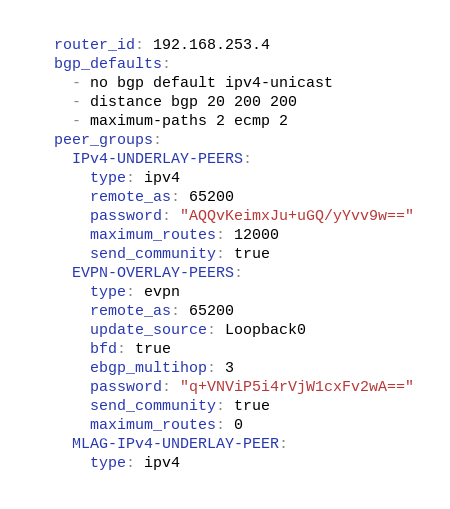<code> <loc_0><loc_0><loc_500><loc_500><_YAML_>  router_id: 192.168.253.4
  bgp_defaults:
    - no bgp default ipv4-unicast
    - distance bgp 20 200 200
    - maximum-paths 2 ecmp 2
  peer_groups:
    IPv4-UNDERLAY-PEERS:
      type: ipv4
      remote_as: 65200
      password: "AQQvKeimxJu+uGQ/yYvv9w=="
      maximum_routes: 12000
      send_community: true
    EVPN-OVERLAY-PEERS:
      type: evpn
      remote_as: 65200
      update_source: Loopback0
      bfd: true
      ebgp_multihop: 3
      password: "q+VNViP5i4rVjW1cxFv2wA=="
      send_community: true
      maximum_routes: 0
    MLAG-IPv4-UNDERLAY-PEER:
      type: ipv4</code> 